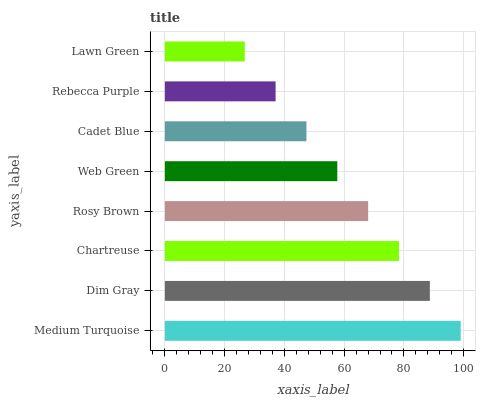Is Lawn Green the minimum?
Answer yes or no. Yes. Is Medium Turquoise the maximum?
Answer yes or no. Yes. Is Dim Gray the minimum?
Answer yes or no. No. Is Dim Gray the maximum?
Answer yes or no. No. Is Medium Turquoise greater than Dim Gray?
Answer yes or no. Yes. Is Dim Gray less than Medium Turquoise?
Answer yes or no. Yes. Is Dim Gray greater than Medium Turquoise?
Answer yes or no. No. Is Medium Turquoise less than Dim Gray?
Answer yes or no. No. Is Rosy Brown the high median?
Answer yes or no. Yes. Is Web Green the low median?
Answer yes or no. Yes. Is Medium Turquoise the high median?
Answer yes or no. No. Is Chartreuse the low median?
Answer yes or no. No. 